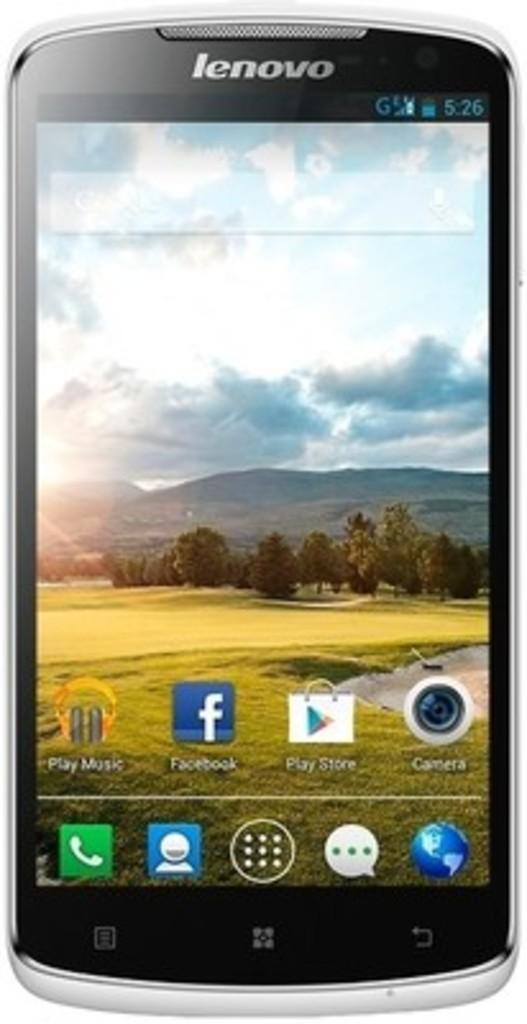<image>
Write a terse but informative summary of the picture. lenovo android phone with background of green grass, trees, and mountains in the distance 